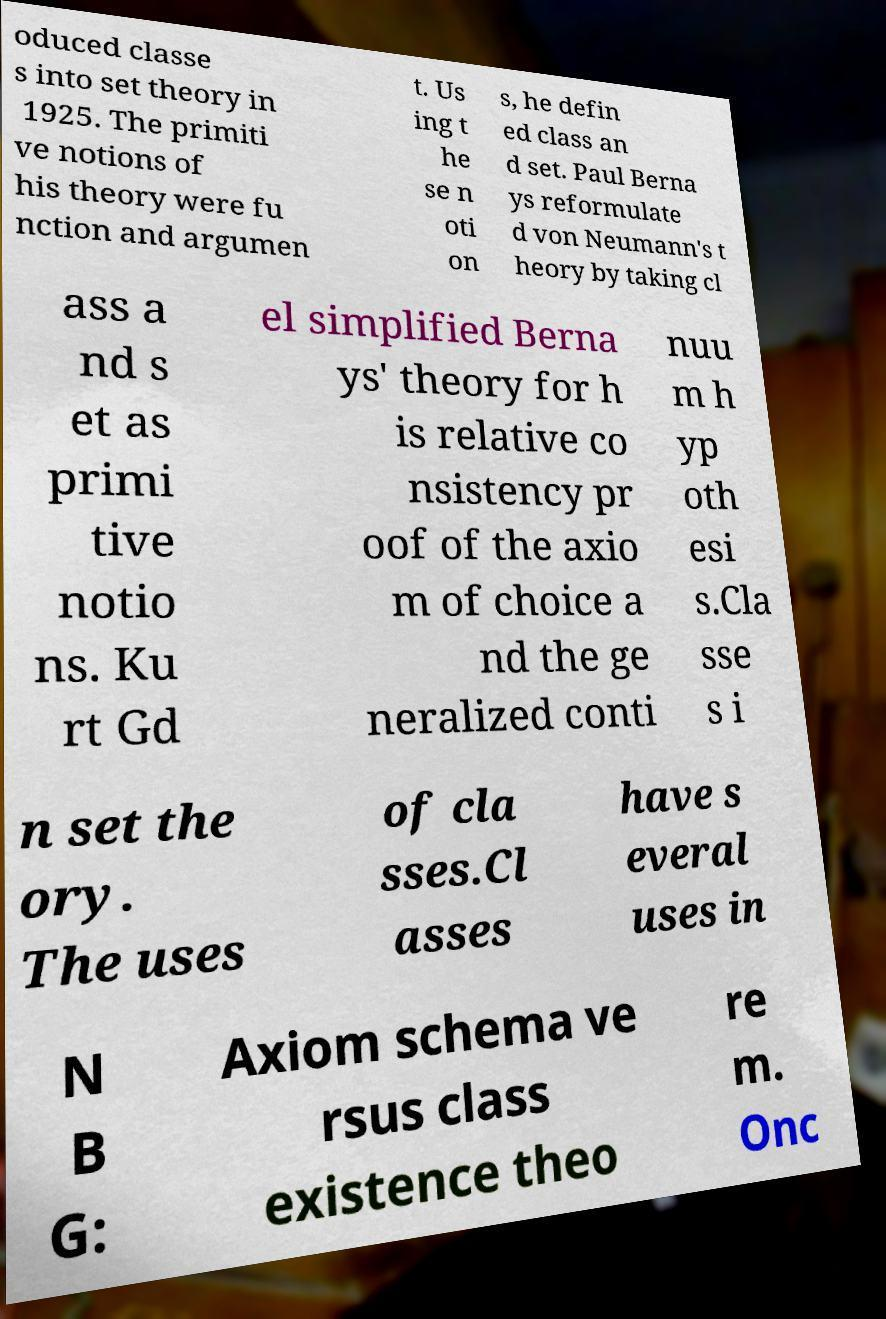Can you accurately transcribe the text from the provided image for me? oduced classe s into set theory in 1925. The primiti ve notions of his theory were fu nction and argumen t. Us ing t he se n oti on s, he defin ed class an d set. Paul Berna ys reformulate d von Neumann's t heory by taking cl ass a nd s et as primi tive notio ns. Ku rt Gd el simplified Berna ys' theory for h is relative co nsistency pr oof of the axio m of choice a nd the ge neralized conti nuu m h yp oth esi s.Cla sse s i n set the ory. The uses of cla sses.Cl asses have s everal uses in N B G: Axiom schema ve rsus class existence theo re m. Onc 